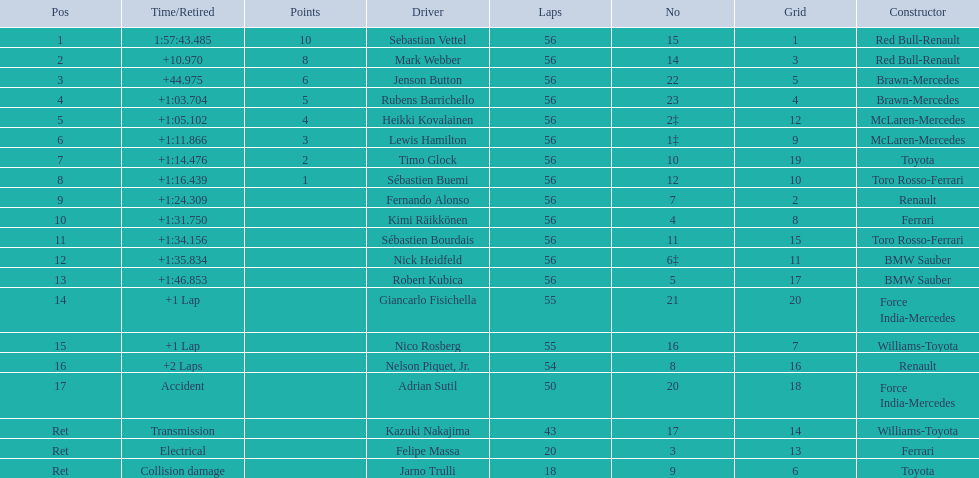Which drivers took part in the 2009 chinese grand prix? Sebastian Vettel, Mark Webber, Jenson Button, Rubens Barrichello, Heikki Kovalainen, Lewis Hamilton, Timo Glock, Sébastien Buemi, Fernando Alonso, Kimi Räikkönen, Sébastien Bourdais, Nick Heidfeld, Robert Kubica, Giancarlo Fisichella, Nico Rosberg, Nelson Piquet, Jr., Adrian Sutil, Kazuki Nakajima, Felipe Massa, Jarno Trulli. Of these, who completed all 56 laps? Sebastian Vettel, Mark Webber, Jenson Button, Rubens Barrichello, Heikki Kovalainen, Lewis Hamilton, Timo Glock, Sébastien Buemi, Fernando Alonso, Kimi Räikkönen, Sébastien Bourdais, Nick Heidfeld, Robert Kubica. Of these, which did ferrari not participate as a constructor? Sebastian Vettel, Mark Webber, Jenson Button, Rubens Barrichello, Heikki Kovalainen, Lewis Hamilton, Timo Glock, Fernando Alonso, Kimi Räikkönen, Nick Heidfeld, Robert Kubica. Of the remaining, which is in pos 1? Sebastian Vettel. Why did the  toyota retire Collision damage. Parse the table in full. {'header': ['Pos', 'Time/Retired', 'Points', 'Driver', 'Laps', 'No', 'Grid', 'Constructor'], 'rows': [['1', '1:57:43.485', '10', 'Sebastian Vettel', '56', '15', '1', 'Red Bull-Renault'], ['2', '+10.970', '8', 'Mark Webber', '56', '14', '3', 'Red Bull-Renault'], ['3', '+44.975', '6', 'Jenson Button', '56', '22', '5', 'Brawn-Mercedes'], ['4', '+1:03.704', '5', 'Rubens Barrichello', '56', '23', '4', 'Brawn-Mercedes'], ['5', '+1:05.102', '4', 'Heikki Kovalainen', '56', '2‡', '12', 'McLaren-Mercedes'], ['6', '+1:11.866', '3', 'Lewis Hamilton', '56', '1‡', '9', 'McLaren-Mercedes'], ['7', '+1:14.476', '2', 'Timo Glock', '56', '10', '19', 'Toyota'], ['8', '+1:16.439', '1', 'Sébastien Buemi', '56', '12', '10', 'Toro Rosso-Ferrari'], ['9', '+1:24.309', '', 'Fernando Alonso', '56', '7', '2', 'Renault'], ['10', '+1:31.750', '', 'Kimi Räikkönen', '56', '4', '8', 'Ferrari'], ['11', '+1:34.156', '', 'Sébastien Bourdais', '56', '11', '15', 'Toro Rosso-Ferrari'], ['12', '+1:35.834', '', 'Nick Heidfeld', '56', '6‡', '11', 'BMW Sauber'], ['13', '+1:46.853', '', 'Robert Kubica', '56', '5', '17', 'BMW Sauber'], ['14', '+1 Lap', '', 'Giancarlo Fisichella', '55', '21', '20', 'Force India-Mercedes'], ['15', '+1 Lap', '', 'Nico Rosberg', '55', '16', '7', 'Williams-Toyota'], ['16', '+2 Laps', '', 'Nelson Piquet, Jr.', '54', '8', '16', 'Renault'], ['17', 'Accident', '', 'Adrian Sutil', '50', '20', '18', 'Force India-Mercedes'], ['Ret', 'Transmission', '', 'Kazuki Nakajima', '43', '17', '14', 'Williams-Toyota'], ['Ret', 'Electrical', '', 'Felipe Massa', '20', '3', '13', 'Ferrari'], ['Ret', 'Collision damage', '', 'Jarno Trulli', '18', '9', '6', 'Toyota']]} What was the drivers name? Jarno Trulli. 